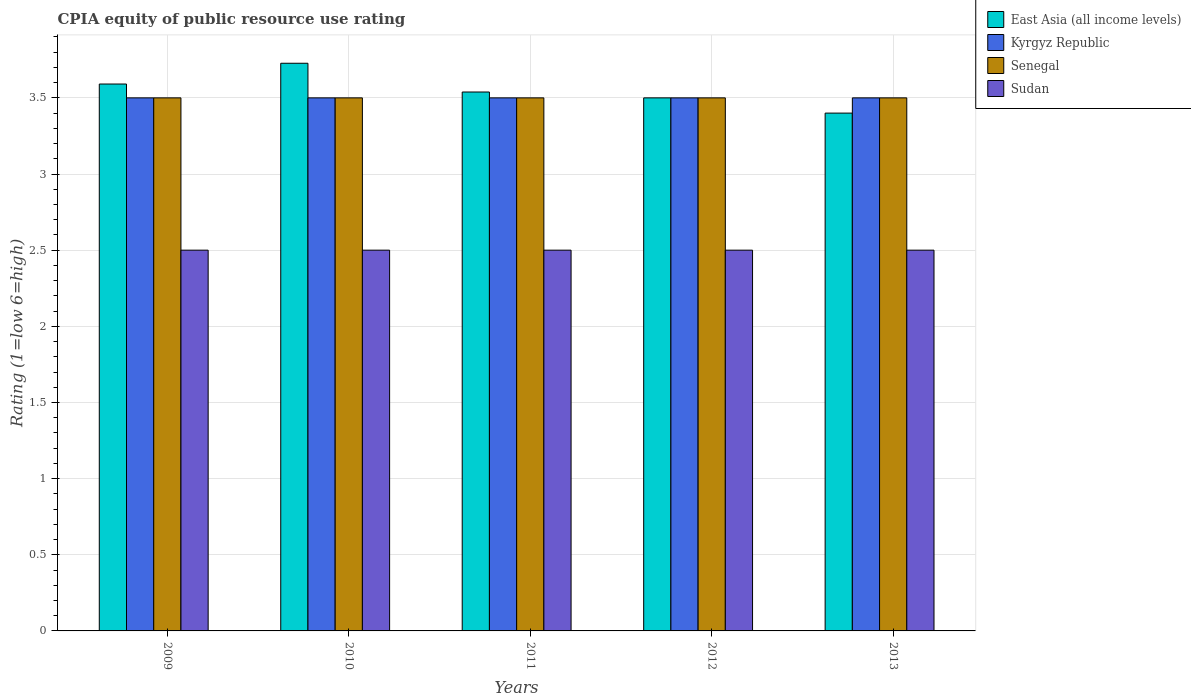Are the number of bars on each tick of the X-axis equal?
Provide a succinct answer. Yes. In how many cases, is the number of bars for a given year not equal to the number of legend labels?
Offer a very short reply. 0. In which year was the CPIA rating in Senegal maximum?
Offer a terse response. 2009. What is the total CPIA rating in Sudan in the graph?
Your answer should be very brief. 12.5. What is the difference between the CPIA rating in Sudan in 2012 and that in 2013?
Offer a terse response. 0. What is the difference between the CPIA rating in Kyrgyz Republic in 2010 and the CPIA rating in Senegal in 2012?
Your answer should be compact. 0. What is the ratio of the CPIA rating in Senegal in 2009 to that in 2011?
Offer a terse response. 1. What is the difference between the highest and the second highest CPIA rating in East Asia (all income levels)?
Provide a succinct answer. 0.14. In how many years, is the CPIA rating in East Asia (all income levels) greater than the average CPIA rating in East Asia (all income levels) taken over all years?
Offer a terse response. 2. Is it the case that in every year, the sum of the CPIA rating in Sudan and CPIA rating in Kyrgyz Republic is greater than the sum of CPIA rating in East Asia (all income levels) and CPIA rating in Senegal?
Your answer should be compact. No. What does the 3rd bar from the left in 2011 represents?
Give a very brief answer. Senegal. What does the 4th bar from the right in 2009 represents?
Your answer should be compact. East Asia (all income levels). What is the difference between two consecutive major ticks on the Y-axis?
Your answer should be very brief. 0.5. Does the graph contain any zero values?
Make the answer very short. No. How are the legend labels stacked?
Your response must be concise. Vertical. What is the title of the graph?
Make the answer very short. CPIA equity of public resource use rating. Does "High income" appear as one of the legend labels in the graph?
Provide a short and direct response. No. What is the Rating (1=low 6=high) of East Asia (all income levels) in 2009?
Your response must be concise. 3.59. What is the Rating (1=low 6=high) of Kyrgyz Republic in 2009?
Provide a succinct answer. 3.5. What is the Rating (1=low 6=high) in Senegal in 2009?
Give a very brief answer. 3.5. What is the Rating (1=low 6=high) in Sudan in 2009?
Ensure brevity in your answer.  2.5. What is the Rating (1=low 6=high) of East Asia (all income levels) in 2010?
Ensure brevity in your answer.  3.73. What is the Rating (1=low 6=high) in Kyrgyz Republic in 2010?
Make the answer very short. 3.5. What is the Rating (1=low 6=high) in Sudan in 2010?
Make the answer very short. 2.5. What is the Rating (1=low 6=high) in East Asia (all income levels) in 2011?
Your answer should be very brief. 3.54. What is the Rating (1=low 6=high) in Senegal in 2011?
Your answer should be very brief. 3.5. What is the Rating (1=low 6=high) in Sudan in 2011?
Provide a succinct answer. 2.5. What is the Rating (1=low 6=high) in East Asia (all income levels) in 2012?
Keep it short and to the point. 3.5. What is the Rating (1=low 6=high) of Sudan in 2012?
Provide a succinct answer. 2.5. What is the Rating (1=low 6=high) in East Asia (all income levels) in 2013?
Your answer should be very brief. 3.4. Across all years, what is the maximum Rating (1=low 6=high) in East Asia (all income levels)?
Provide a short and direct response. 3.73. Across all years, what is the maximum Rating (1=low 6=high) in Senegal?
Ensure brevity in your answer.  3.5. Across all years, what is the maximum Rating (1=low 6=high) of Sudan?
Give a very brief answer. 2.5. Across all years, what is the minimum Rating (1=low 6=high) in Kyrgyz Republic?
Provide a succinct answer. 3.5. What is the total Rating (1=low 6=high) in East Asia (all income levels) in the graph?
Provide a short and direct response. 17.76. What is the total Rating (1=low 6=high) of Sudan in the graph?
Provide a succinct answer. 12.5. What is the difference between the Rating (1=low 6=high) of East Asia (all income levels) in 2009 and that in 2010?
Offer a terse response. -0.14. What is the difference between the Rating (1=low 6=high) of Kyrgyz Republic in 2009 and that in 2010?
Your answer should be very brief. 0. What is the difference between the Rating (1=low 6=high) in Senegal in 2009 and that in 2010?
Offer a very short reply. 0. What is the difference between the Rating (1=low 6=high) of East Asia (all income levels) in 2009 and that in 2011?
Give a very brief answer. 0.05. What is the difference between the Rating (1=low 6=high) of Kyrgyz Republic in 2009 and that in 2011?
Ensure brevity in your answer.  0. What is the difference between the Rating (1=low 6=high) in Senegal in 2009 and that in 2011?
Give a very brief answer. 0. What is the difference between the Rating (1=low 6=high) in Sudan in 2009 and that in 2011?
Your answer should be very brief. 0. What is the difference between the Rating (1=low 6=high) in East Asia (all income levels) in 2009 and that in 2012?
Your answer should be compact. 0.09. What is the difference between the Rating (1=low 6=high) in Kyrgyz Republic in 2009 and that in 2012?
Ensure brevity in your answer.  0. What is the difference between the Rating (1=low 6=high) in Senegal in 2009 and that in 2012?
Give a very brief answer. 0. What is the difference between the Rating (1=low 6=high) of East Asia (all income levels) in 2009 and that in 2013?
Provide a short and direct response. 0.19. What is the difference between the Rating (1=low 6=high) in Kyrgyz Republic in 2009 and that in 2013?
Provide a short and direct response. 0. What is the difference between the Rating (1=low 6=high) in Sudan in 2009 and that in 2013?
Your answer should be very brief. 0. What is the difference between the Rating (1=low 6=high) in East Asia (all income levels) in 2010 and that in 2011?
Make the answer very short. 0.19. What is the difference between the Rating (1=low 6=high) of Kyrgyz Republic in 2010 and that in 2011?
Offer a very short reply. 0. What is the difference between the Rating (1=low 6=high) in Senegal in 2010 and that in 2011?
Your answer should be compact. 0. What is the difference between the Rating (1=low 6=high) in East Asia (all income levels) in 2010 and that in 2012?
Offer a very short reply. 0.23. What is the difference between the Rating (1=low 6=high) of Senegal in 2010 and that in 2012?
Give a very brief answer. 0. What is the difference between the Rating (1=low 6=high) of East Asia (all income levels) in 2010 and that in 2013?
Offer a terse response. 0.33. What is the difference between the Rating (1=low 6=high) of East Asia (all income levels) in 2011 and that in 2012?
Your answer should be compact. 0.04. What is the difference between the Rating (1=low 6=high) of Kyrgyz Republic in 2011 and that in 2012?
Give a very brief answer. 0. What is the difference between the Rating (1=low 6=high) in Senegal in 2011 and that in 2012?
Give a very brief answer. 0. What is the difference between the Rating (1=low 6=high) of Sudan in 2011 and that in 2012?
Make the answer very short. 0. What is the difference between the Rating (1=low 6=high) in East Asia (all income levels) in 2011 and that in 2013?
Keep it short and to the point. 0.14. What is the difference between the Rating (1=low 6=high) in Senegal in 2011 and that in 2013?
Offer a terse response. 0. What is the difference between the Rating (1=low 6=high) in Sudan in 2011 and that in 2013?
Your answer should be compact. 0. What is the difference between the Rating (1=low 6=high) of Sudan in 2012 and that in 2013?
Your response must be concise. 0. What is the difference between the Rating (1=low 6=high) in East Asia (all income levels) in 2009 and the Rating (1=low 6=high) in Kyrgyz Republic in 2010?
Your answer should be compact. 0.09. What is the difference between the Rating (1=low 6=high) in East Asia (all income levels) in 2009 and the Rating (1=low 6=high) in Senegal in 2010?
Ensure brevity in your answer.  0.09. What is the difference between the Rating (1=low 6=high) of Kyrgyz Republic in 2009 and the Rating (1=low 6=high) of Senegal in 2010?
Ensure brevity in your answer.  0. What is the difference between the Rating (1=low 6=high) in Senegal in 2009 and the Rating (1=low 6=high) in Sudan in 2010?
Your response must be concise. 1. What is the difference between the Rating (1=low 6=high) of East Asia (all income levels) in 2009 and the Rating (1=low 6=high) of Kyrgyz Republic in 2011?
Provide a short and direct response. 0.09. What is the difference between the Rating (1=low 6=high) of East Asia (all income levels) in 2009 and the Rating (1=low 6=high) of Senegal in 2011?
Offer a terse response. 0.09. What is the difference between the Rating (1=low 6=high) in East Asia (all income levels) in 2009 and the Rating (1=low 6=high) in Sudan in 2011?
Your answer should be very brief. 1.09. What is the difference between the Rating (1=low 6=high) in Kyrgyz Republic in 2009 and the Rating (1=low 6=high) in Senegal in 2011?
Ensure brevity in your answer.  0. What is the difference between the Rating (1=low 6=high) in Senegal in 2009 and the Rating (1=low 6=high) in Sudan in 2011?
Your answer should be very brief. 1. What is the difference between the Rating (1=low 6=high) of East Asia (all income levels) in 2009 and the Rating (1=low 6=high) of Kyrgyz Republic in 2012?
Provide a succinct answer. 0.09. What is the difference between the Rating (1=low 6=high) in East Asia (all income levels) in 2009 and the Rating (1=low 6=high) in Senegal in 2012?
Provide a succinct answer. 0.09. What is the difference between the Rating (1=low 6=high) of Kyrgyz Republic in 2009 and the Rating (1=low 6=high) of Senegal in 2012?
Offer a very short reply. 0. What is the difference between the Rating (1=low 6=high) of Kyrgyz Republic in 2009 and the Rating (1=low 6=high) of Sudan in 2012?
Provide a succinct answer. 1. What is the difference between the Rating (1=low 6=high) in East Asia (all income levels) in 2009 and the Rating (1=low 6=high) in Kyrgyz Republic in 2013?
Your response must be concise. 0.09. What is the difference between the Rating (1=low 6=high) of East Asia (all income levels) in 2009 and the Rating (1=low 6=high) of Senegal in 2013?
Your response must be concise. 0.09. What is the difference between the Rating (1=low 6=high) of Kyrgyz Republic in 2009 and the Rating (1=low 6=high) of Sudan in 2013?
Offer a very short reply. 1. What is the difference between the Rating (1=low 6=high) of Senegal in 2009 and the Rating (1=low 6=high) of Sudan in 2013?
Your answer should be very brief. 1. What is the difference between the Rating (1=low 6=high) of East Asia (all income levels) in 2010 and the Rating (1=low 6=high) of Kyrgyz Republic in 2011?
Make the answer very short. 0.23. What is the difference between the Rating (1=low 6=high) of East Asia (all income levels) in 2010 and the Rating (1=low 6=high) of Senegal in 2011?
Your response must be concise. 0.23. What is the difference between the Rating (1=low 6=high) of East Asia (all income levels) in 2010 and the Rating (1=low 6=high) of Sudan in 2011?
Provide a succinct answer. 1.23. What is the difference between the Rating (1=low 6=high) in Kyrgyz Republic in 2010 and the Rating (1=low 6=high) in Senegal in 2011?
Offer a terse response. 0. What is the difference between the Rating (1=low 6=high) in East Asia (all income levels) in 2010 and the Rating (1=low 6=high) in Kyrgyz Republic in 2012?
Offer a terse response. 0.23. What is the difference between the Rating (1=low 6=high) of East Asia (all income levels) in 2010 and the Rating (1=low 6=high) of Senegal in 2012?
Make the answer very short. 0.23. What is the difference between the Rating (1=low 6=high) of East Asia (all income levels) in 2010 and the Rating (1=low 6=high) of Sudan in 2012?
Give a very brief answer. 1.23. What is the difference between the Rating (1=low 6=high) of Kyrgyz Republic in 2010 and the Rating (1=low 6=high) of Sudan in 2012?
Provide a succinct answer. 1. What is the difference between the Rating (1=low 6=high) of East Asia (all income levels) in 2010 and the Rating (1=low 6=high) of Kyrgyz Republic in 2013?
Your answer should be compact. 0.23. What is the difference between the Rating (1=low 6=high) of East Asia (all income levels) in 2010 and the Rating (1=low 6=high) of Senegal in 2013?
Your answer should be compact. 0.23. What is the difference between the Rating (1=low 6=high) of East Asia (all income levels) in 2010 and the Rating (1=low 6=high) of Sudan in 2013?
Your answer should be compact. 1.23. What is the difference between the Rating (1=low 6=high) of Kyrgyz Republic in 2010 and the Rating (1=low 6=high) of Sudan in 2013?
Provide a succinct answer. 1. What is the difference between the Rating (1=low 6=high) of East Asia (all income levels) in 2011 and the Rating (1=low 6=high) of Kyrgyz Republic in 2012?
Make the answer very short. 0.04. What is the difference between the Rating (1=low 6=high) in East Asia (all income levels) in 2011 and the Rating (1=low 6=high) in Senegal in 2012?
Make the answer very short. 0.04. What is the difference between the Rating (1=low 6=high) in East Asia (all income levels) in 2011 and the Rating (1=low 6=high) in Sudan in 2012?
Provide a short and direct response. 1.04. What is the difference between the Rating (1=low 6=high) in Kyrgyz Republic in 2011 and the Rating (1=low 6=high) in Sudan in 2012?
Provide a short and direct response. 1. What is the difference between the Rating (1=low 6=high) of East Asia (all income levels) in 2011 and the Rating (1=low 6=high) of Kyrgyz Republic in 2013?
Your response must be concise. 0.04. What is the difference between the Rating (1=low 6=high) of East Asia (all income levels) in 2011 and the Rating (1=low 6=high) of Senegal in 2013?
Ensure brevity in your answer.  0.04. What is the difference between the Rating (1=low 6=high) of Kyrgyz Republic in 2011 and the Rating (1=low 6=high) of Sudan in 2013?
Offer a very short reply. 1. What is the difference between the Rating (1=low 6=high) in Senegal in 2011 and the Rating (1=low 6=high) in Sudan in 2013?
Your answer should be compact. 1. What is the difference between the Rating (1=low 6=high) in East Asia (all income levels) in 2012 and the Rating (1=low 6=high) in Kyrgyz Republic in 2013?
Provide a succinct answer. 0. What is the difference between the Rating (1=low 6=high) in East Asia (all income levels) in 2012 and the Rating (1=low 6=high) in Senegal in 2013?
Your response must be concise. 0. What is the difference between the Rating (1=low 6=high) of Kyrgyz Republic in 2012 and the Rating (1=low 6=high) of Senegal in 2013?
Your answer should be very brief. 0. What is the average Rating (1=low 6=high) in East Asia (all income levels) per year?
Offer a very short reply. 3.55. What is the average Rating (1=low 6=high) of Kyrgyz Republic per year?
Your response must be concise. 3.5. What is the average Rating (1=low 6=high) of Sudan per year?
Make the answer very short. 2.5. In the year 2009, what is the difference between the Rating (1=low 6=high) in East Asia (all income levels) and Rating (1=low 6=high) in Kyrgyz Republic?
Your answer should be compact. 0.09. In the year 2009, what is the difference between the Rating (1=low 6=high) of East Asia (all income levels) and Rating (1=low 6=high) of Senegal?
Your answer should be very brief. 0.09. In the year 2009, what is the difference between the Rating (1=low 6=high) of Senegal and Rating (1=low 6=high) of Sudan?
Keep it short and to the point. 1. In the year 2010, what is the difference between the Rating (1=low 6=high) of East Asia (all income levels) and Rating (1=low 6=high) of Kyrgyz Republic?
Offer a terse response. 0.23. In the year 2010, what is the difference between the Rating (1=low 6=high) of East Asia (all income levels) and Rating (1=low 6=high) of Senegal?
Your answer should be very brief. 0.23. In the year 2010, what is the difference between the Rating (1=low 6=high) of East Asia (all income levels) and Rating (1=low 6=high) of Sudan?
Offer a terse response. 1.23. In the year 2010, what is the difference between the Rating (1=low 6=high) in Kyrgyz Republic and Rating (1=low 6=high) in Sudan?
Give a very brief answer. 1. In the year 2010, what is the difference between the Rating (1=low 6=high) in Senegal and Rating (1=low 6=high) in Sudan?
Provide a succinct answer. 1. In the year 2011, what is the difference between the Rating (1=low 6=high) of East Asia (all income levels) and Rating (1=low 6=high) of Kyrgyz Republic?
Ensure brevity in your answer.  0.04. In the year 2011, what is the difference between the Rating (1=low 6=high) of East Asia (all income levels) and Rating (1=low 6=high) of Senegal?
Offer a very short reply. 0.04. In the year 2011, what is the difference between the Rating (1=low 6=high) in East Asia (all income levels) and Rating (1=low 6=high) in Sudan?
Provide a succinct answer. 1.04. In the year 2011, what is the difference between the Rating (1=low 6=high) of Senegal and Rating (1=low 6=high) of Sudan?
Keep it short and to the point. 1. In the year 2012, what is the difference between the Rating (1=low 6=high) of Senegal and Rating (1=low 6=high) of Sudan?
Offer a terse response. 1. In the year 2013, what is the difference between the Rating (1=low 6=high) of East Asia (all income levels) and Rating (1=low 6=high) of Kyrgyz Republic?
Offer a terse response. -0.1. In the year 2013, what is the difference between the Rating (1=low 6=high) in East Asia (all income levels) and Rating (1=low 6=high) in Sudan?
Your answer should be compact. 0.9. In the year 2013, what is the difference between the Rating (1=low 6=high) of Kyrgyz Republic and Rating (1=low 6=high) of Senegal?
Give a very brief answer. 0. What is the ratio of the Rating (1=low 6=high) of East Asia (all income levels) in 2009 to that in 2010?
Offer a very short reply. 0.96. What is the ratio of the Rating (1=low 6=high) in East Asia (all income levels) in 2009 to that in 2011?
Keep it short and to the point. 1.01. What is the ratio of the Rating (1=low 6=high) of Kyrgyz Republic in 2009 to that in 2011?
Keep it short and to the point. 1. What is the ratio of the Rating (1=low 6=high) in Kyrgyz Republic in 2009 to that in 2012?
Your response must be concise. 1. What is the ratio of the Rating (1=low 6=high) in Senegal in 2009 to that in 2012?
Offer a terse response. 1. What is the ratio of the Rating (1=low 6=high) of East Asia (all income levels) in 2009 to that in 2013?
Give a very brief answer. 1.06. What is the ratio of the Rating (1=low 6=high) of East Asia (all income levels) in 2010 to that in 2011?
Offer a very short reply. 1.05. What is the ratio of the Rating (1=low 6=high) of Senegal in 2010 to that in 2011?
Offer a terse response. 1. What is the ratio of the Rating (1=low 6=high) of Sudan in 2010 to that in 2011?
Offer a terse response. 1. What is the ratio of the Rating (1=low 6=high) of East Asia (all income levels) in 2010 to that in 2012?
Offer a terse response. 1.06. What is the ratio of the Rating (1=low 6=high) of Kyrgyz Republic in 2010 to that in 2012?
Provide a short and direct response. 1. What is the ratio of the Rating (1=low 6=high) of Senegal in 2010 to that in 2012?
Ensure brevity in your answer.  1. What is the ratio of the Rating (1=low 6=high) of Sudan in 2010 to that in 2012?
Provide a short and direct response. 1. What is the ratio of the Rating (1=low 6=high) of East Asia (all income levels) in 2010 to that in 2013?
Your answer should be compact. 1.1. What is the ratio of the Rating (1=low 6=high) in Kyrgyz Republic in 2010 to that in 2013?
Your answer should be compact. 1. What is the ratio of the Rating (1=low 6=high) in Senegal in 2010 to that in 2013?
Provide a succinct answer. 1. What is the ratio of the Rating (1=low 6=high) of Kyrgyz Republic in 2011 to that in 2012?
Your answer should be compact. 1. What is the ratio of the Rating (1=low 6=high) in East Asia (all income levels) in 2011 to that in 2013?
Your answer should be compact. 1.04. What is the ratio of the Rating (1=low 6=high) in East Asia (all income levels) in 2012 to that in 2013?
Provide a succinct answer. 1.03. What is the ratio of the Rating (1=low 6=high) in Kyrgyz Republic in 2012 to that in 2013?
Give a very brief answer. 1. What is the difference between the highest and the second highest Rating (1=low 6=high) in East Asia (all income levels)?
Provide a short and direct response. 0.14. What is the difference between the highest and the second highest Rating (1=low 6=high) in Kyrgyz Republic?
Ensure brevity in your answer.  0. What is the difference between the highest and the lowest Rating (1=low 6=high) of East Asia (all income levels)?
Offer a terse response. 0.33. What is the difference between the highest and the lowest Rating (1=low 6=high) in Sudan?
Give a very brief answer. 0. 